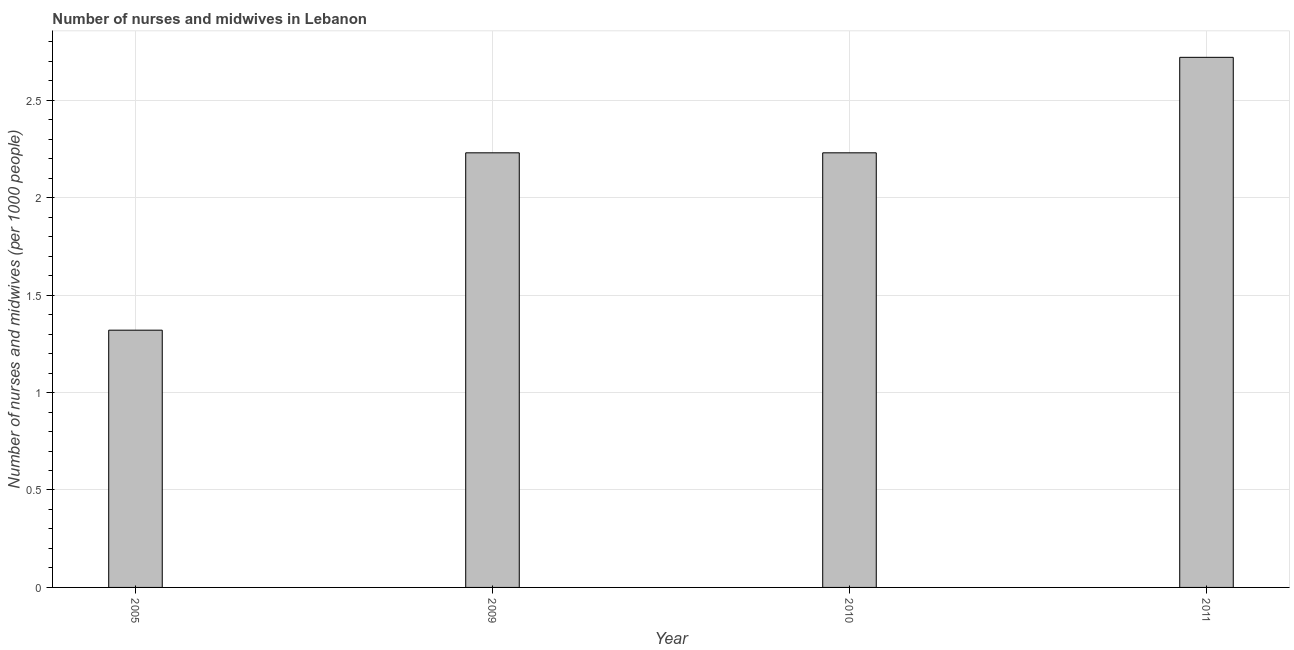Does the graph contain any zero values?
Ensure brevity in your answer.  No. What is the title of the graph?
Offer a very short reply. Number of nurses and midwives in Lebanon. What is the label or title of the X-axis?
Make the answer very short. Year. What is the label or title of the Y-axis?
Give a very brief answer. Number of nurses and midwives (per 1000 people). What is the number of nurses and midwives in 2005?
Your answer should be very brief. 1.32. Across all years, what is the maximum number of nurses and midwives?
Ensure brevity in your answer.  2.72. Across all years, what is the minimum number of nurses and midwives?
Make the answer very short. 1.32. In which year was the number of nurses and midwives maximum?
Your answer should be compact. 2011. What is the difference between the number of nurses and midwives in 2010 and 2011?
Ensure brevity in your answer.  -0.49. What is the average number of nurses and midwives per year?
Your response must be concise. 2.12. What is the median number of nurses and midwives?
Give a very brief answer. 2.23. Do a majority of the years between 2011 and 2005 (inclusive) have number of nurses and midwives greater than 0.6 ?
Ensure brevity in your answer.  Yes. What is the ratio of the number of nurses and midwives in 2010 to that in 2011?
Your answer should be very brief. 0.82. Is the number of nurses and midwives in 2009 less than that in 2010?
Offer a terse response. No. What is the difference between the highest and the second highest number of nurses and midwives?
Keep it short and to the point. 0.49. In how many years, is the number of nurses and midwives greater than the average number of nurses and midwives taken over all years?
Provide a succinct answer. 3. Are all the bars in the graph horizontal?
Offer a very short reply. No. How many years are there in the graph?
Keep it short and to the point. 4. What is the difference between two consecutive major ticks on the Y-axis?
Your answer should be compact. 0.5. What is the Number of nurses and midwives (per 1000 people) of 2005?
Give a very brief answer. 1.32. What is the Number of nurses and midwives (per 1000 people) of 2009?
Offer a terse response. 2.23. What is the Number of nurses and midwives (per 1000 people) in 2010?
Provide a short and direct response. 2.23. What is the Number of nurses and midwives (per 1000 people) of 2011?
Provide a succinct answer. 2.72. What is the difference between the Number of nurses and midwives (per 1000 people) in 2005 and 2009?
Your response must be concise. -0.91. What is the difference between the Number of nurses and midwives (per 1000 people) in 2005 and 2010?
Offer a very short reply. -0.91. What is the difference between the Number of nurses and midwives (per 1000 people) in 2009 and 2011?
Your answer should be compact. -0.49. What is the difference between the Number of nurses and midwives (per 1000 people) in 2010 and 2011?
Your response must be concise. -0.49. What is the ratio of the Number of nurses and midwives (per 1000 people) in 2005 to that in 2009?
Your response must be concise. 0.59. What is the ratio of the Number of nurses and midwives (per 1000 people) in 2005 to that in 2010?
Give a very brief answer. 0.59. What is the ratio of the Number of nurses and midwives (per 1000 people) in 2005 to that in 2011?
Make the answer very short. 0.48. What is the ratio of the Number of nurses and midwives (per 1000 people) in 2009 to that in 2010?
Your response must be concise. 1. What is the ratio of the Number of nurses and midwives (per 1000 people) in 2009 to that in 2011?
Make the answer very short. 0.82. What is the ratio of the Number of nurses and midwives (per 1000 people) in 2010 to that in 2011?
Give a very brief answer. 0.82. 